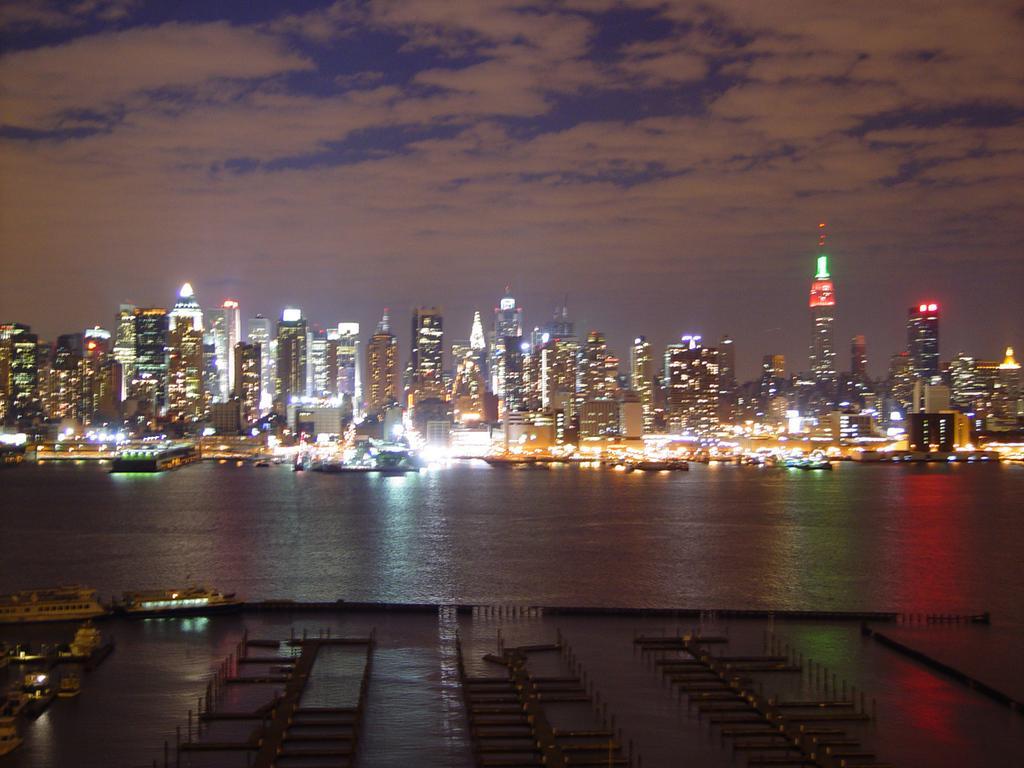In one or two sentences, can you explain what this image depicts? In this picture there is water at the bottom side of the image and there are skyscrapers in the center of the image. 